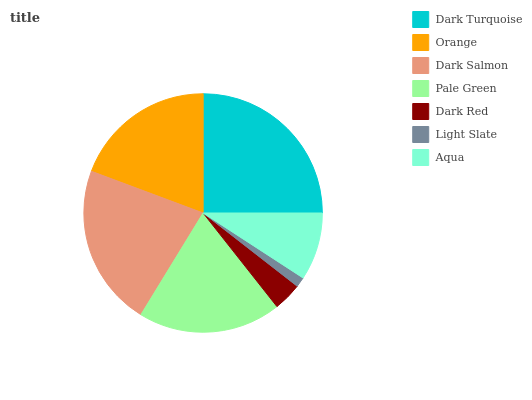Is Light Slate the minimum?
Answer yes or no. Yes. Is Dark Turquoise the maximum?
Answer yes or no. Yes. Is Orange the minimum?
Answer yes or no. No. Is Orange the maximum?
Answer yes or no. No. Is Dark Turquoise greater than Orange?
Answer yes or no. Yes. Is Orange less than Dark Turquoise?
Answer yes or no. Yes. Is Orange greater than Dark Turquoise?
Answer yes or no. No. Is Dark Turquoise less than Orange?
Answer yes or no. No. Is Orange the high median?
Answer yes or no. Yes. Is Orange the low median?
Answer yes or no. Yes. Is Aqua the high median?
Answer yes or no. No. Is Light Slate the low median?
Answer yes or no. No. 